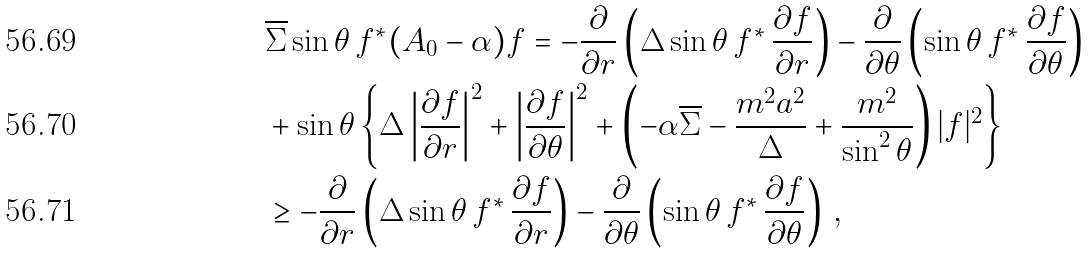Convert formula to latex. <formula><loc_0><loc_0><loc_500><loc_500>& \overline { \Sigma } \sin \theta \, f ^ { * } ( A _ { 0 } - \alpha ) f = - \frac { \partial } { \partial r } \left ( \Delta \sin \theta \, f ^ { * } \, \frac { \partial f } { \partial r } \right ) - \frac { \partial } { \partial \theta } \left ( \sin \theta \, f ^ { * } \, \frac { \partial f } { \partial \theta } \right ) \\ & + \sin \theta \left \{ \Delta \left | \frac { \partial f } { \partial r } \right | ^ { 2 } + \left | \frac { \partial f } { \partial \theta } \right | ^ { 2 } + \left ( - \alpha \overline { \Sigma } - \frac { m ^ { 2 } a ^ { 2 } } { \Delta } + \frac { m ^ { 2 } } { \sin ^ { 2 } \theta } \right ) | f | ^ { 2 } \right \} \\ & \geq - \frac { \partial } { \partial r } \left ( \Delta \sin \theta \, f ^ { * } \, \frac { \partial f } { \partial r } \right ) - \frac { \partial } { \partial \theta } \left ( \sin \theta \, f ^ { * } \, \frac { \partial f } { \partial \theta } \right ) \, ,</formula> 